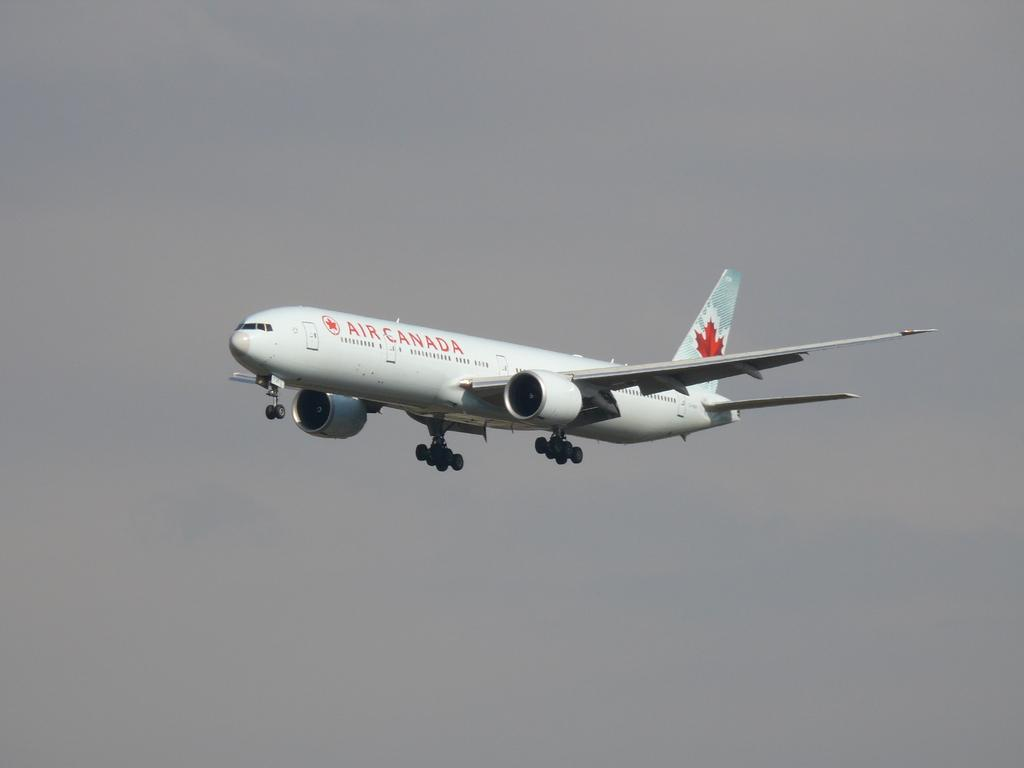<image>
Present a compact description of the photo's key features. an Air Canada plane in the sky about to land 